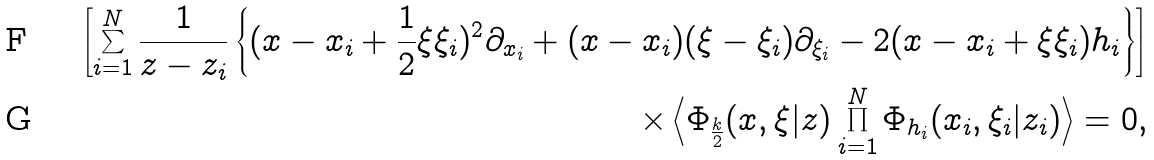Convert formula to latex. <formula><loc_0><loc_0><loc_500><loc_500>\left [ \sum _ { i = 1 } ^ { N } \frac { 1 } { z - z _ { i } } \left \{ ( x - x _ { i } + \frac { 1 } { 2 } \xi \xi _ { i } ) ^ { 2 } \partial _ { x _ { i } } + ( x - x _ { i } ) ( \xi - \xi _ { i } ) \partial _ { \xi _ { i } } - 2 ( x - x _ { i } + \xi \xi _ { i } ) h _ { i } \right \} \right ] \\ \times \left \langle \Phi _ { \frac { k } { 2 } } ( x , \xi | z ) \prod _ { i = 1 } ^ { N } \Phi _ { h _ { i } } ( x _ { i } , \xi _ { i } | z _ { i } ) \right \rangle = 0 ,</formula> 